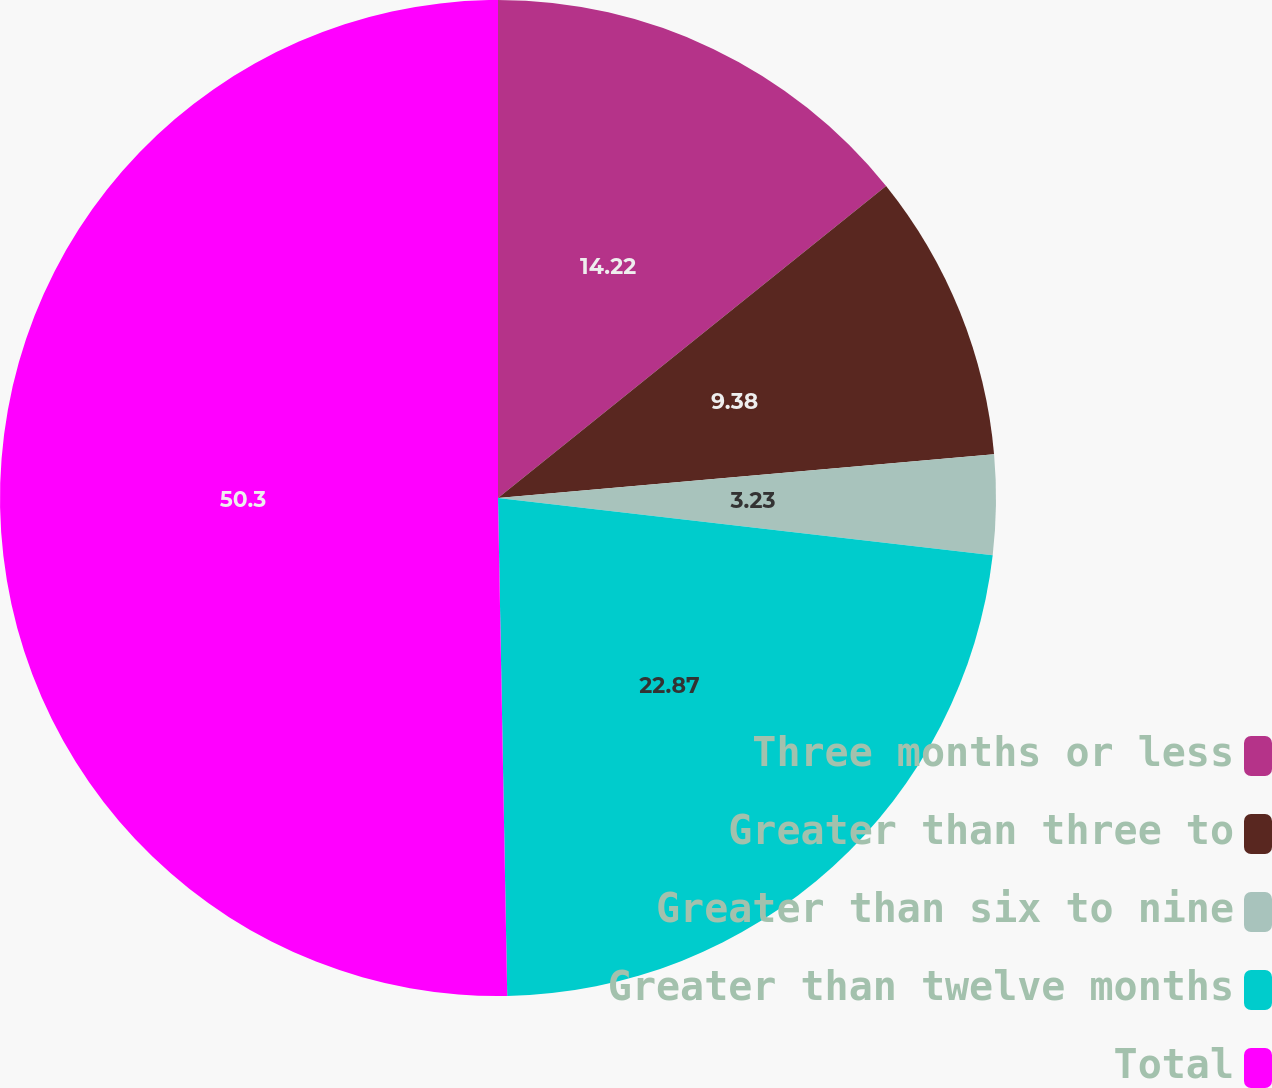Convert chart to OTSL. <chart><loc_0><loc_0><loc_500><loc_500><pie_chart><fcel>Three months or less<fcel>Greater than three to<fcel>Greater than six to nine<fcel>Greater than twelve months<fcel>Total<nl><fcel>14.22%<fcel>9.38%<fcel>3.23%<fcel>22.87%<fcel>50.29%<nl></chart> 